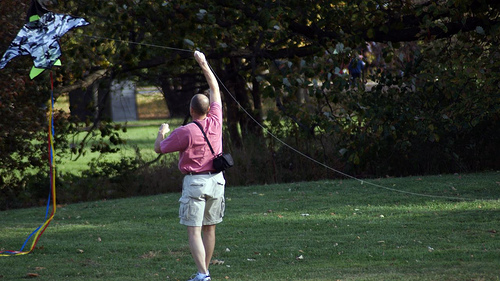<image>What type of sport are they playing? I don't know what type of sport they are playing. It seems they might be flying kites. What type of sport are they playing? I am not sure what type of sport they are playing. It can be seen as flying kites or kite flying. 